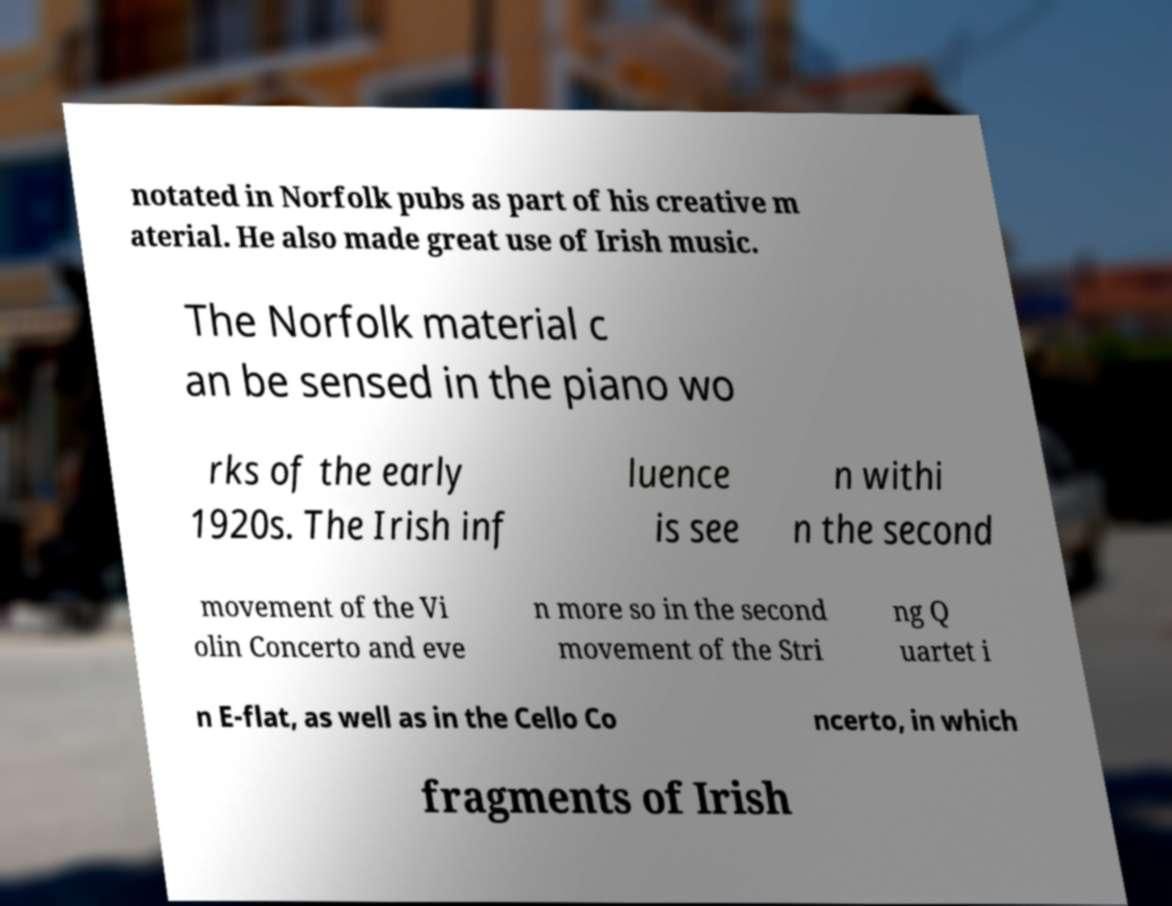Can you read and provide the text displayed in the image?This photo seems to have some interesting text. Can you extract and type it out for me? notated in Norfolk pubs as part of his creative m aterial. He also made great use of Irish music. The Norfolk material c an be sensed in the piano wo rks of the early 1920s. The Irish inf luence is see n withi n the second movement of the Vi olin Concerto and eve n more so in the second movement of the Stri ng Q uartet i n E-flat, as well as in the Cello Co ncerto, in which fragments of Irish 